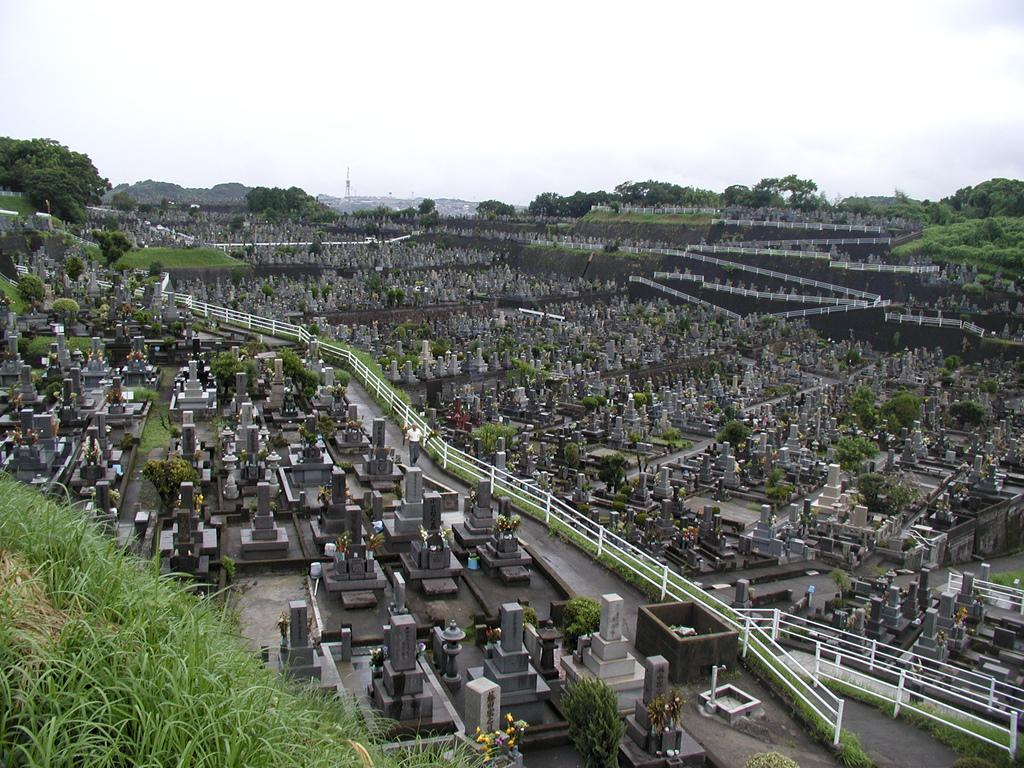What type of structures are in the image? There is a group of buildings in the image. Can you describe the person in the image? There is a person in the image. What type of vegetation is visible at the bottom of the image? Grass is visible at the bottom of the image. What is visible at the top of the image? The sky is visible at the top of the image. What else can be seen in the image besides the buildings and person? Trees are present in the image. Where is the lunchroom located in the image? There is no mention of a lunchroom in the image; it only features a group of buildings, a person, grass, the sky, and trees. 